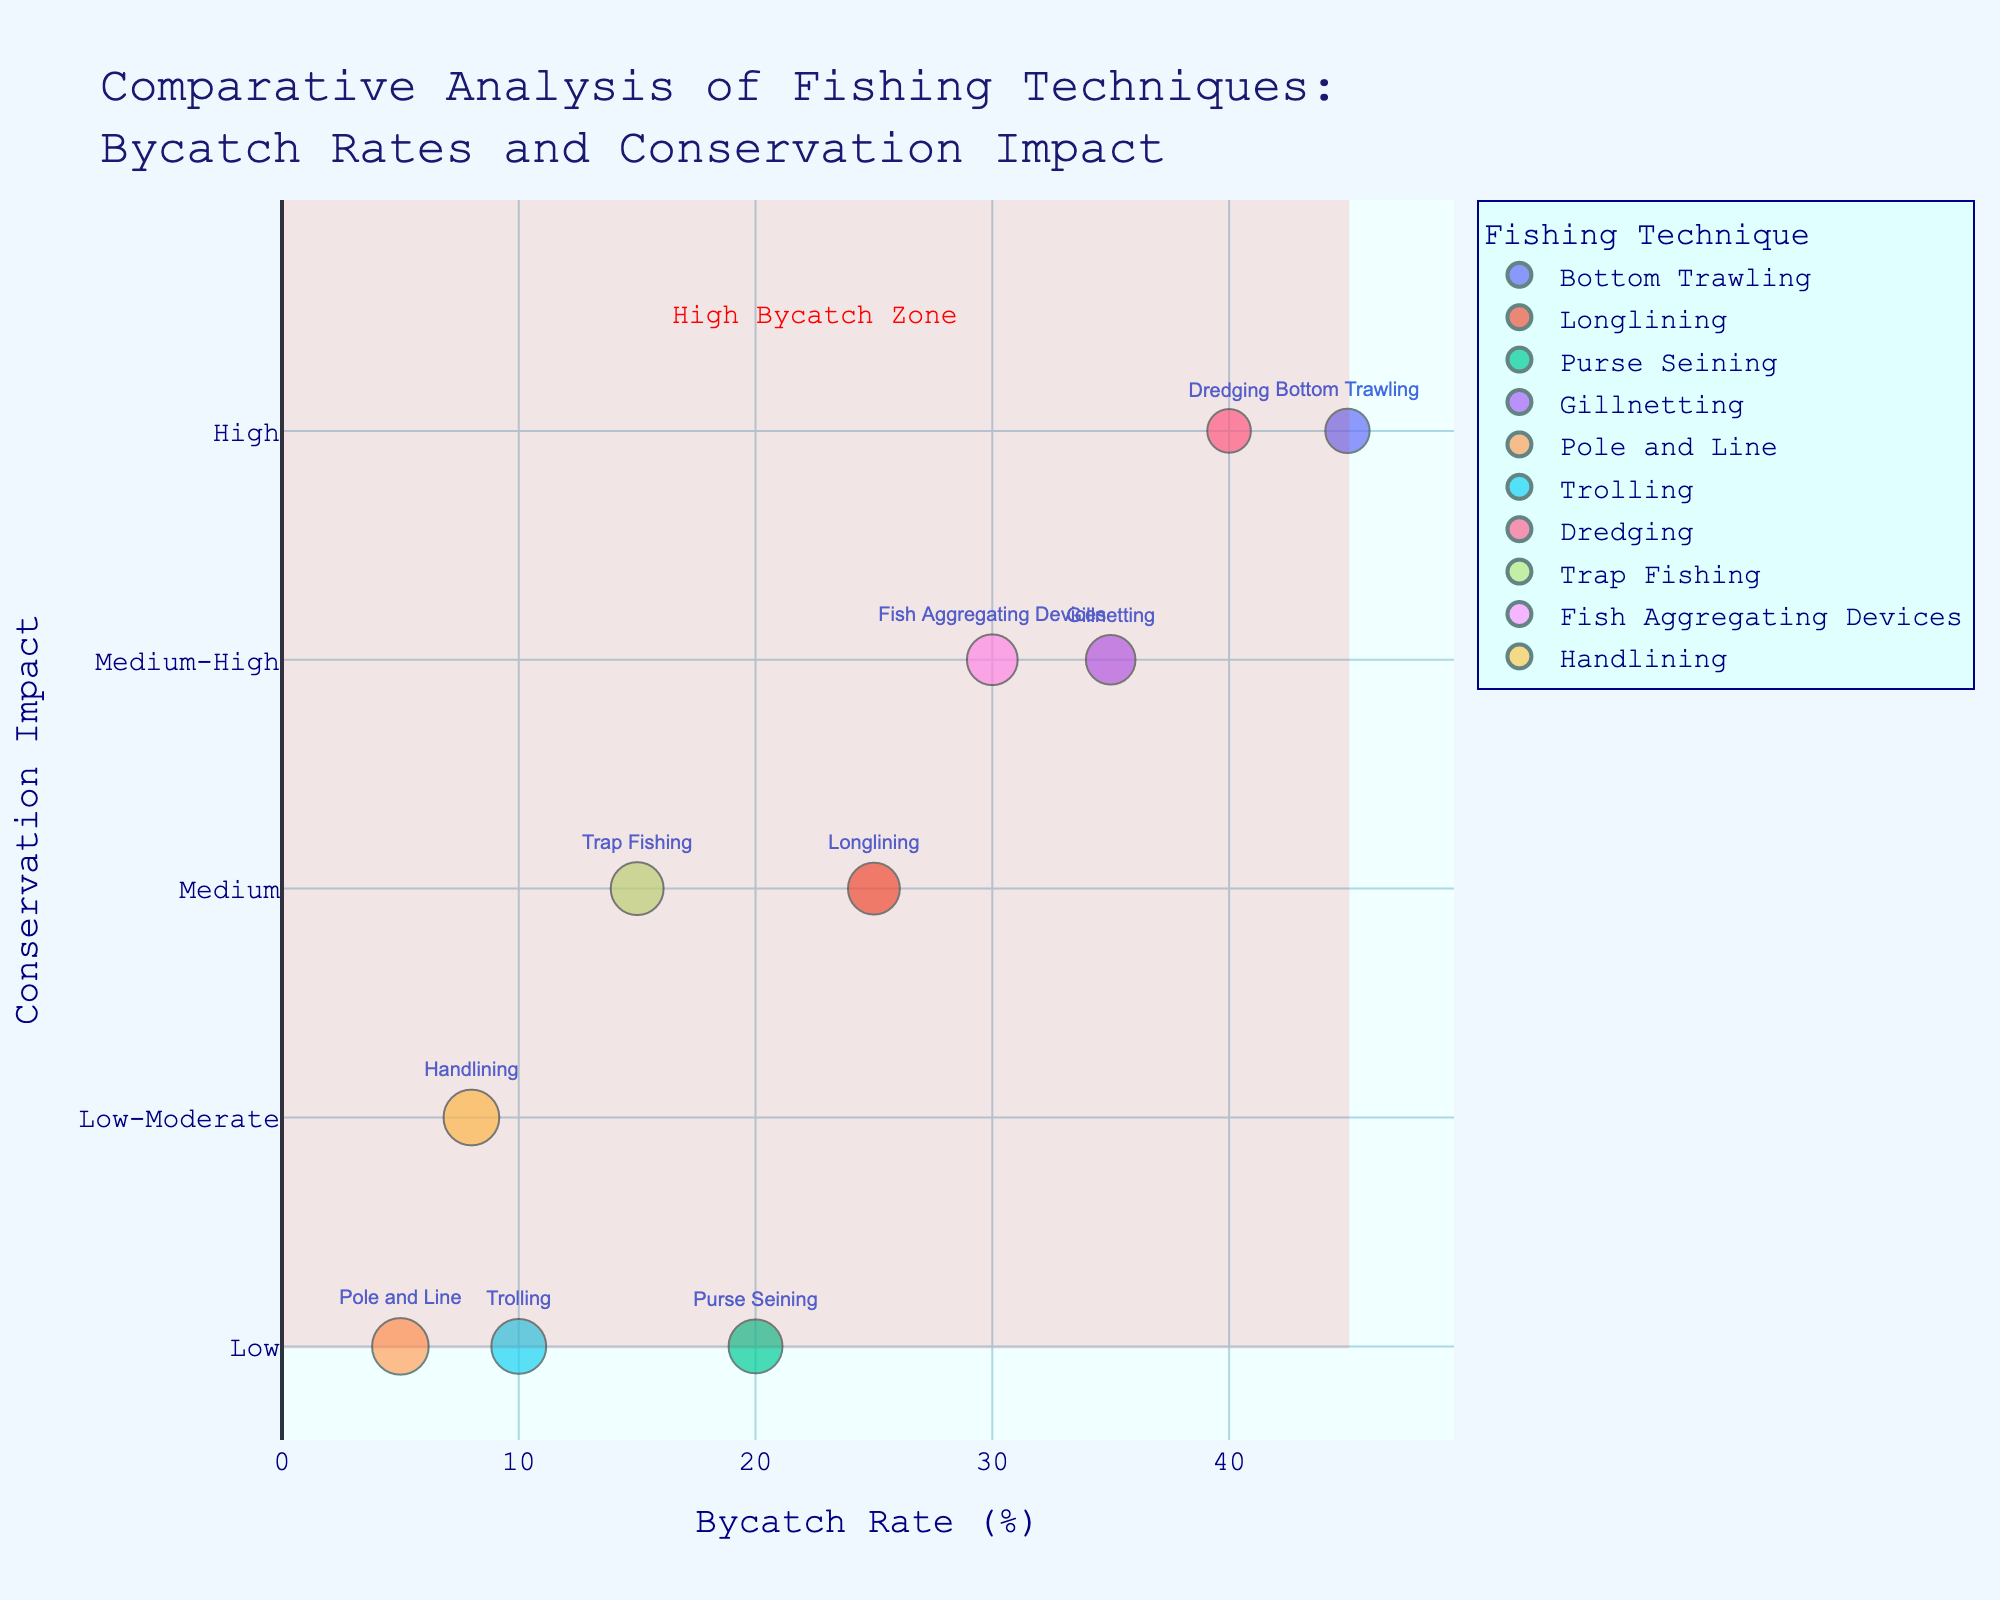how many fishing techniques are shown in the figure? Count the number of unique fishing techniques labeled on the chart. Each bubble represents one fishing technique, and there are ten different bubbles.
Answer: 10 what is the title of the figure? The title of the figure is located at the top and gives an overview of the chart's content.
Answer: Comparative Analysis of Fishing Techniques: Bycatch Rates and Conservation Impact Which fishing technique has the highest bycatch rate? Look at the x-axis labeling 'Bycatch Rate (%)' and find the data point furthest to the right. 'Bottom Trawling' is represented by such a bubble.
Answer: Bottom Trawling which technique has the largest bubble size? Bubble size is scaled based on 'Target Catch Rate (%)'. Locate the bubble with the largest diameter, which corresponds to 'Pole and Line'.
Answer: Pole and Line what's the average bycatch rate for techniques with low conservation impact? Identify bubbles with 'Low' conservation impact and find their bycatch rates: Purse Seining - 20, Pole and Line - 5, Trolling - 10. Calculate the average: (20 + 5 + 10) / 3 = 11.67
Answer: 11.67 Which two techniques have a medium-high conservation impact, and how do their bycatch rates compare? Identify 'Gillnetting' and 'Fish Aggregating Devices' as having 'Medium-High' conservation impact. Gillnetting has a bycatch rate of 35%, while Fish Aggregating Devices have a rate of 30%, making Gillnetting's rate higher.
Answer: Gillnetting has a higher bycatch rate Which technique has the lowest bycatch rate, and what is its conservation impact? Locate the bubble furthest to the left. 'Pole and Line' is the technique with the lowest bycatch rate at 5% and has a 'Low' conservation impact.
Answer: Pole and Line, Low What can be inferred about techniques with high target catch rates? Observe bubble sizes, larger bubbles represent higher target catch rates. Techniques such as 'Pole and Line' and 'Trolling' have large bubbles. Their conservation impacts are Low, suggesting these techniques not only target high catch rates but also possibly reduce ecological damage.
Answer: High target catch rates, Low conservation impacts what is the conservation impact of the technique with the second-highest bycatch rate? Find the second data point from the right for bycatch rate, which is 'Dredging'. It has a conservation impact labeled 'High'.
Answer: High Which fishing technique achieves the best balance between low bycatch rate and high target catch rate? Look for the bubble with a low bycatch rate combined with a large bubble size (indicating high target catch rate). 'Pole and Line' stands out with a bycatch rate of 5% and a target catch rate of 85%.
Answer: Pole and Line 